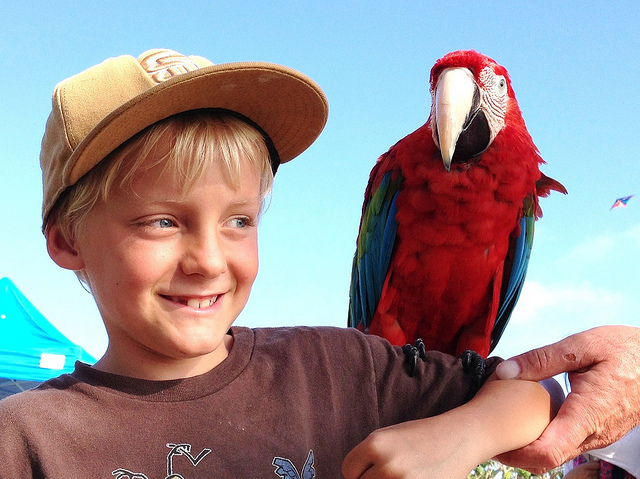Identify the text contained in this image. S 